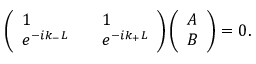Convert formula to latex. <formula><loc_0><loc_0><loc_500><loc_500>\begin{array} { r } { \left ( \begin{array} { l l l } { 1 } & { 1 } \\ { e ^ { - i k _ { - } L } } & { e ^ { - i k _ { + } L } } \end{array} \right ) \left ( \begin{array} { l } { A } \\ { B } \end{array} \right ) = 0 . } \end{array}</formula> 